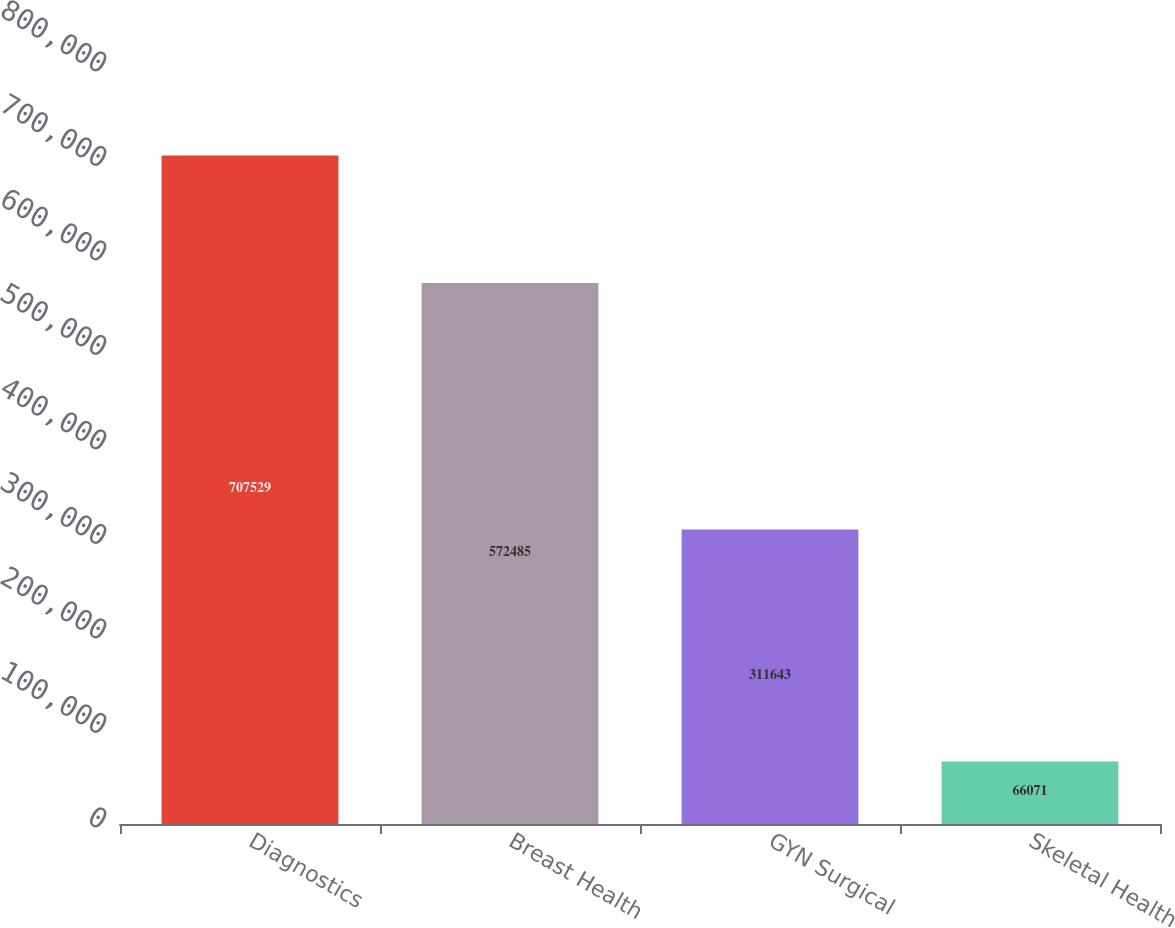Convert chart. <chart><loc_0><loc_0><loc_500><loc_500><bar_chart><fcel>Diagnostics<fcel>Breast Health<fcel>GYN Surgical<fcel>Skeletal Health<nl><fcel>707529<fcel>572485<fcel>311643<fcel>66071<nl></chart> 